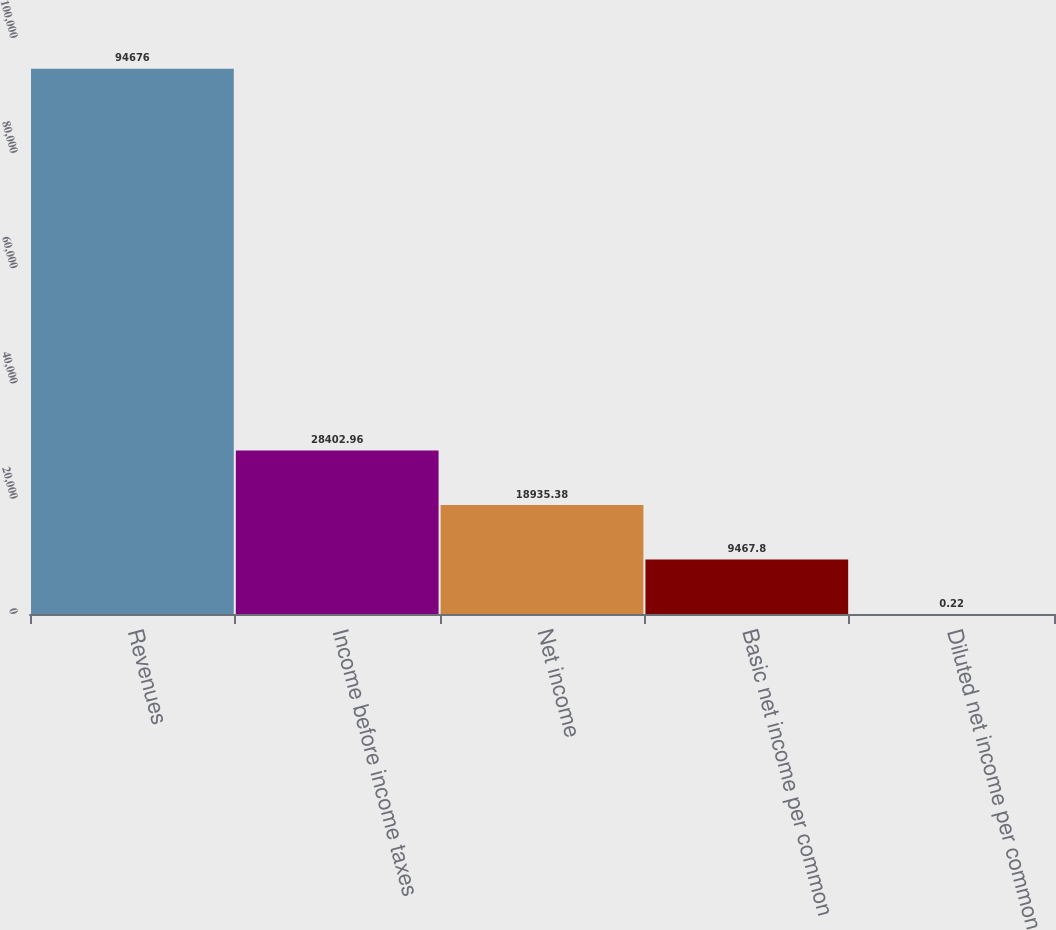<chart> <loc_0><loc_0><loc_500><loc_500><bar_chart><fcel>Revenues<fcel>Income before income taxes<fcel>Net income<fcel>Basic net income per common<fcel>Diluted net income per common<nl><fcel>94676<fcel>28403<fcel>18935.4<fcel>9467.8<fcel>0.22<nl></chart> 